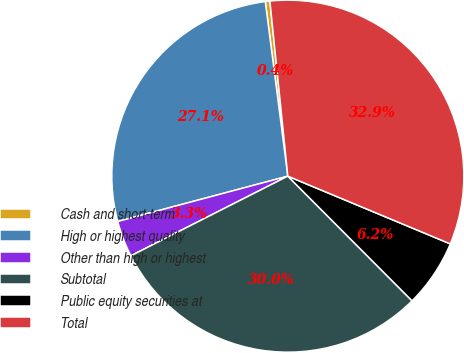Convert chart. <chart><loc_0><loc_0><loc_500><loc_500><pie_chart><fcel>Cash and short-term<fcel>High or highest quality<fcel>Other than high or highest<fcel>Subtotal<fcel>Public equity securities at<fcel>Total<nl><fcel>0.42%<fcel>27.1%<fcel>3.33%<fcel>30.0%<fcel>6.24%<fcel>32.91%<nl></chart> 